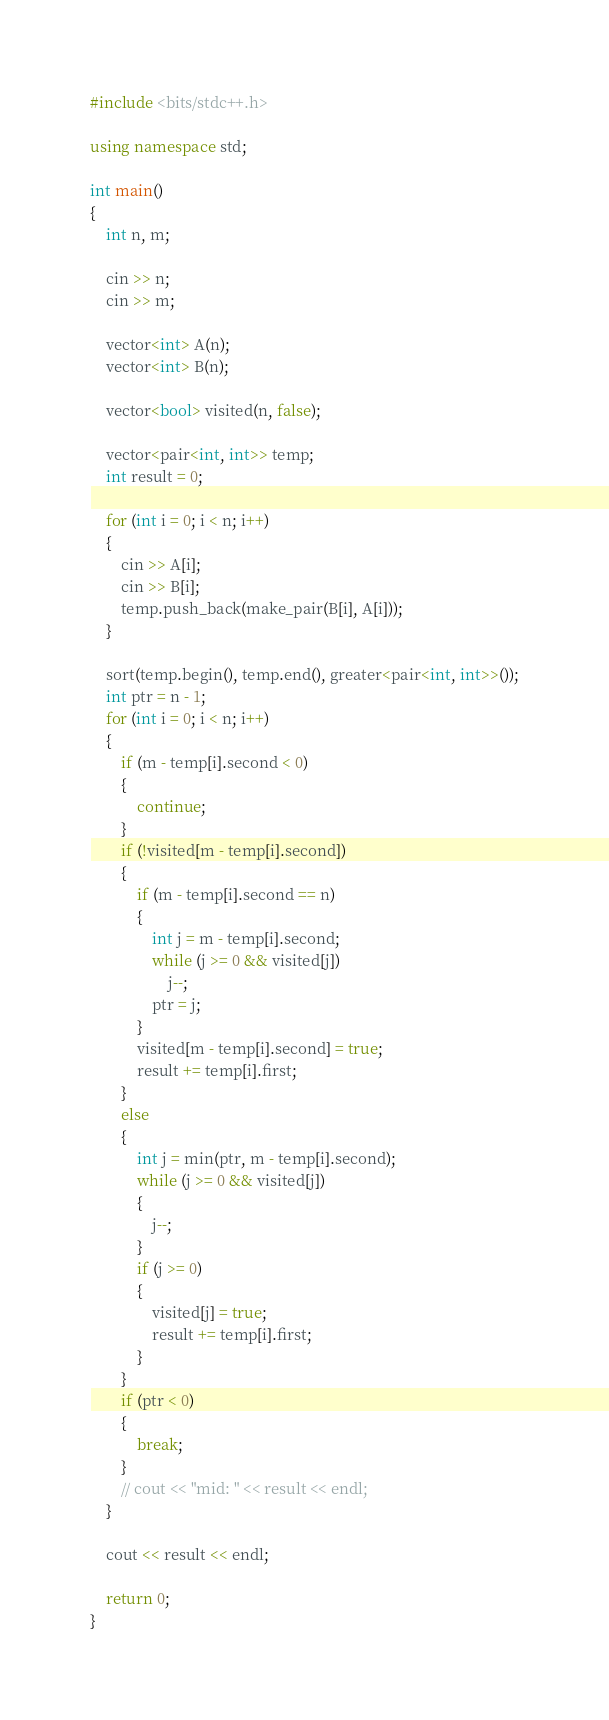Convert code to text. <code><loc_0><loc_0><loc_500><loc_500><_C++_>#include <bits/stdc++.h>

using namespace std;

int main()
{
    int n, m;

    cin >> n;
    cin >> m;

    vector<int> A(n);
    vector<int> B(n);

    vector<bool> visited(n, false);

    vector<pair<int, int>> temp;
    int result = 0;

    for (int i = 0; i < n; i++)
    {
        cin >> A[i];
        cin >> B[i];
        temp.push_back(make_pair(B[i], A[i]));
    }

    sort(temp.begin(), temp.end(), greater<pair<int, int>>());
    int ptr = n - 1;
    for (int i = 0; i < n; i++)
    {
        if (m - temp[i].second < 0)
        {
            continue;
        }
        if (!visited[m - temp[i].second])
        {
            if (m - temp[i].second == n)
            {
                int j = m - temp[i].second;
                while (j >= 0 && visited[j])
                    j--;
                ptr = j;
            }
            visited[m - temp[i].second] = true;
            result += temp[i].first;
        }
        else
        {
            int j = min(ptr, m - temp[i].second);
            while (j >= 0 && visited[j])
            {
                j--;
            }
            if (j >= 0)
            {
                visited[j] = true;
                result += temp[i].first;
            }
        }
        if (ptr < 0)
        {
            break;
        }
        // cout << "mid: " << result << endl;
    }

    cout << result << endl;

    return 0;
}</code> 